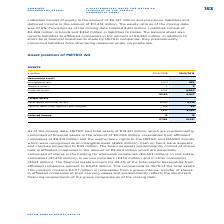According to Metro Ag's financial document, What was METRO's total assets in FY2019? According to the financial document, €18,221 million. The relevant text states: "As of the closing date, METRO had total assets of €18,221 million, which are predominantly..." Also, What was the amount of financial assets in FY2019? According to the financial document, €9,005 million. The relevant text states: "comprised of financial assets in the amount of €9,005 million, receivables from affiliated..." Also, What are the types of assets under Non-current assets in the table? The document contains multiple relevant values: Intangible assets, Tangible assets, Financial assets. From the document: "Intangible assets 1,001 939 Financial assets 9.157 9,005 Intangible assets 1,001 939..." Additionally, In which year was the amount of total assets larger? According to the financial document, 2019. The relevant text states: "€ million 30/9/2018 30/9/2019..." Also, can you calculate: What was the change in total assets in FY2019 from FY2018? Based on the calculation: 18,221-17,389, the result is 832 (in millions). This is based on the information: "17,389 18,221 17,389 18,221..." The key data points involved are: 17,389, 18,221. Also, can you calculate: What was the percentage change in total assets in FY2019 from FY2018? To answer this question, I need to perform calculations using the financial data. The calculation is: (18,221-17,389)/17,389, which equals 4.78 (percentage). This is based on the information: "17,389 18,221 17,389 18,221..." The key data points involved are: 17,389, 18,221. 